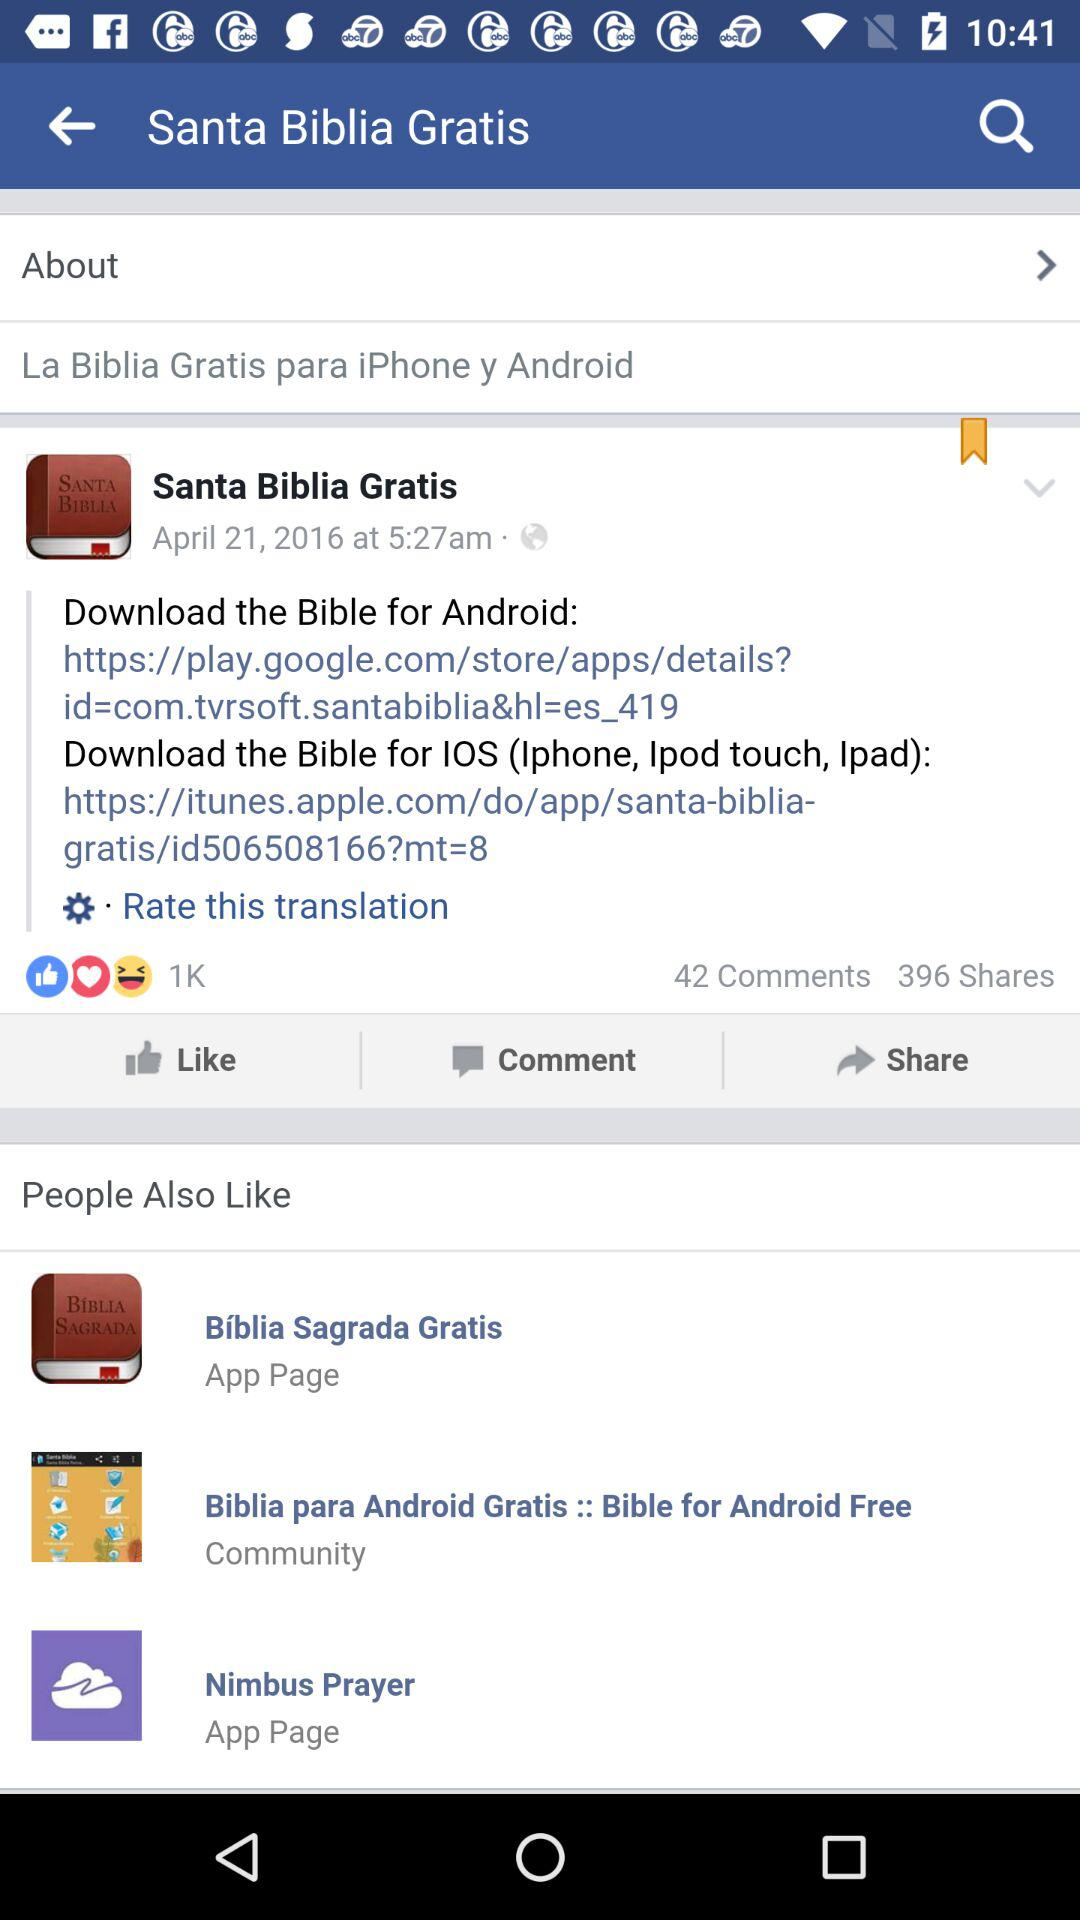What is the application name?
When the provided information is insufficient, respond with <no answer>. <no answer> 